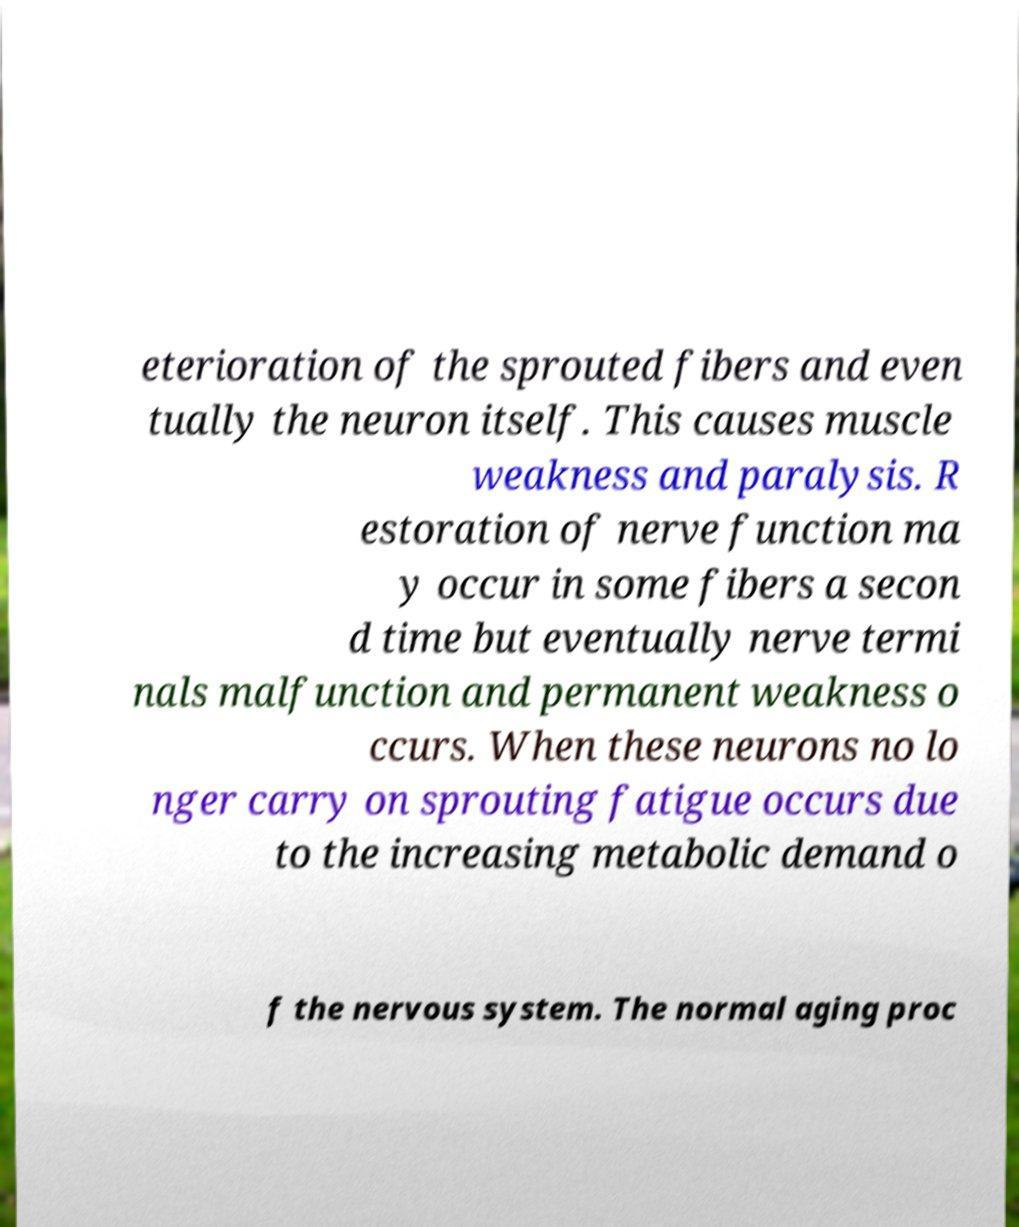What messages or text are displayed in this image? I need them in a readable, typed format. eterioration of the sprouted fibers and even tually the neuron itself. This causes muscle weakness and paralysis. R estoration of nerve function ma y occur in some fibers a secon d time but eventually nerve termi nals malfunction and permanent weakness o ccurs. When these neurons no lo nger carry on sprouting fatigue occurs due to the increasing metabolic demand o f the nervous system. The normal aging proc 